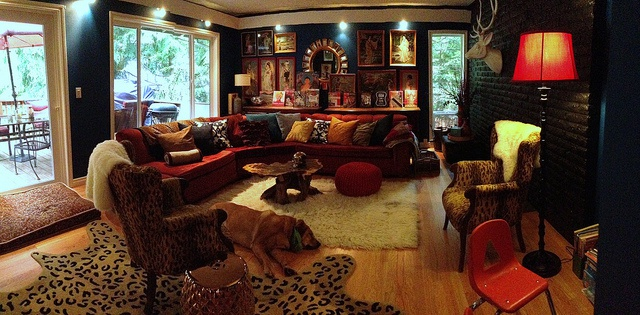Describe the objects in this image and their specific colors. I can see couch in tan, black, maroon, and brown tones, chair in tan, black, maroon, and gray tones, chair in tan, black, maroon, khaki, and olive tones, chair in tan, maroon, brown, and black tones, and dog in tan, maroon, black, and brown tones in this image. 